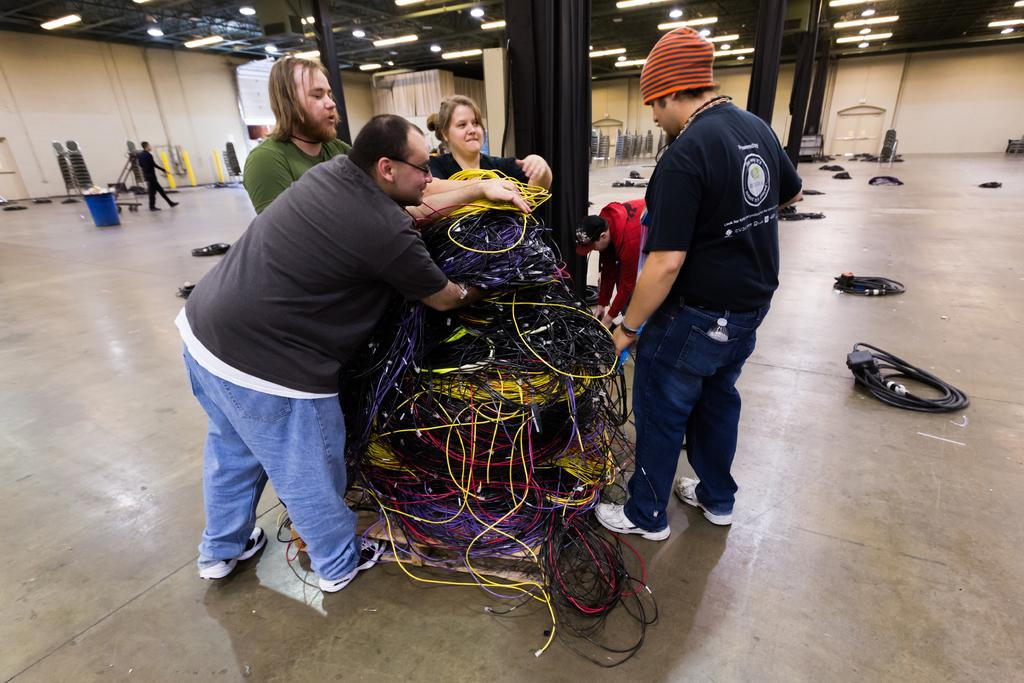How many people are present in the image? There are four persons standing in the image. What are the persons standing in front of? The persons are standing in front of wires. What can be observed about the wires? The wires are in different colors. What else can be seen in the background of the image? There are other objects in the background of the image. What type of sign can be seen hanging from the wires in the image? There is no sign present in the image; the wires are not holding any signs. Can you tell me how many seeds are scattered on the ground near the persons? There are no seeds visible on the ground in the image. 